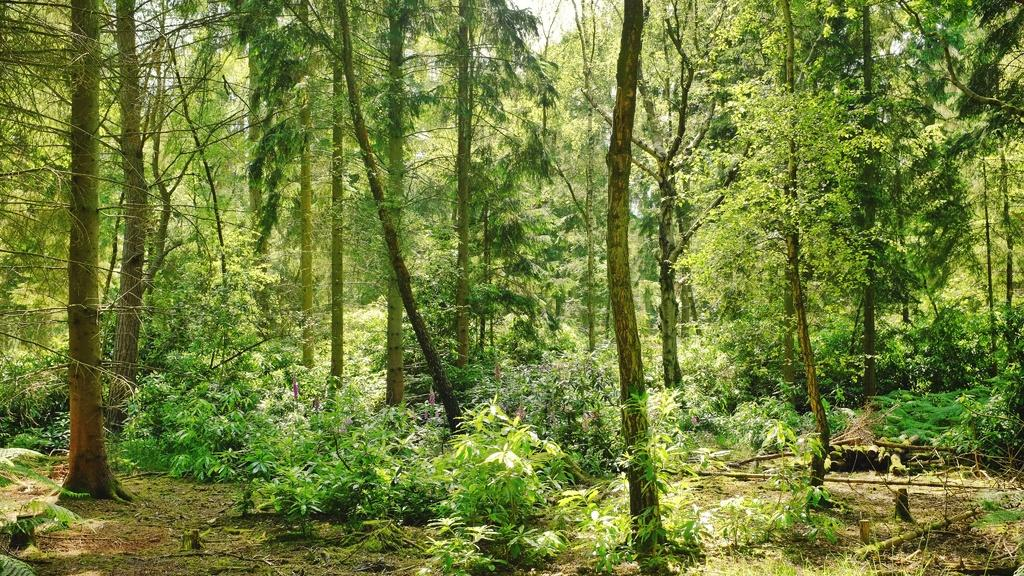What type of environment is shown in the image? The image appears to depict a forest. What types of vegetation can be seen in the image? There are many plants and trees in the image. Where is the parent standing with the mailbox in the image? There is no parent or mailbox present in the image; it depicts a forest with plants and trees. 